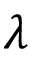<formula> <loc_0><loc_0><loc_500><loc_500>\lambda</formula> 